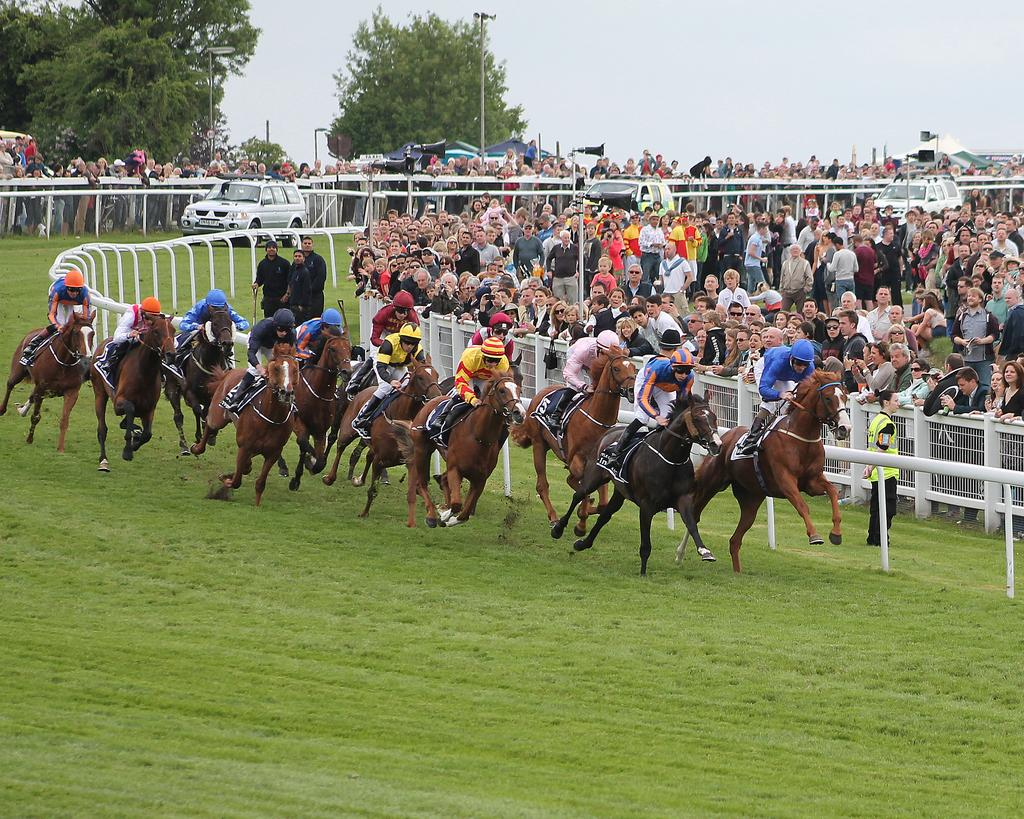What are the people in the image doing? The people in the image are riding horses on the ground. How many people can be seen in the image? There is a group of people in the image. What other objects or vehicles are present in the image? There are cars in the image. What structures can be seen in the image? There are poles and a fence in the image. What type of natural elements are visible in the image? There are trees in the image. What is visible in the background of the image? The sky is visible in the background of the image. What type of stone is being used to crack the silver in the image? There is no stone or silver present in the image; it features people riding horses, cars, poles, a fence, trees, and the sky. 